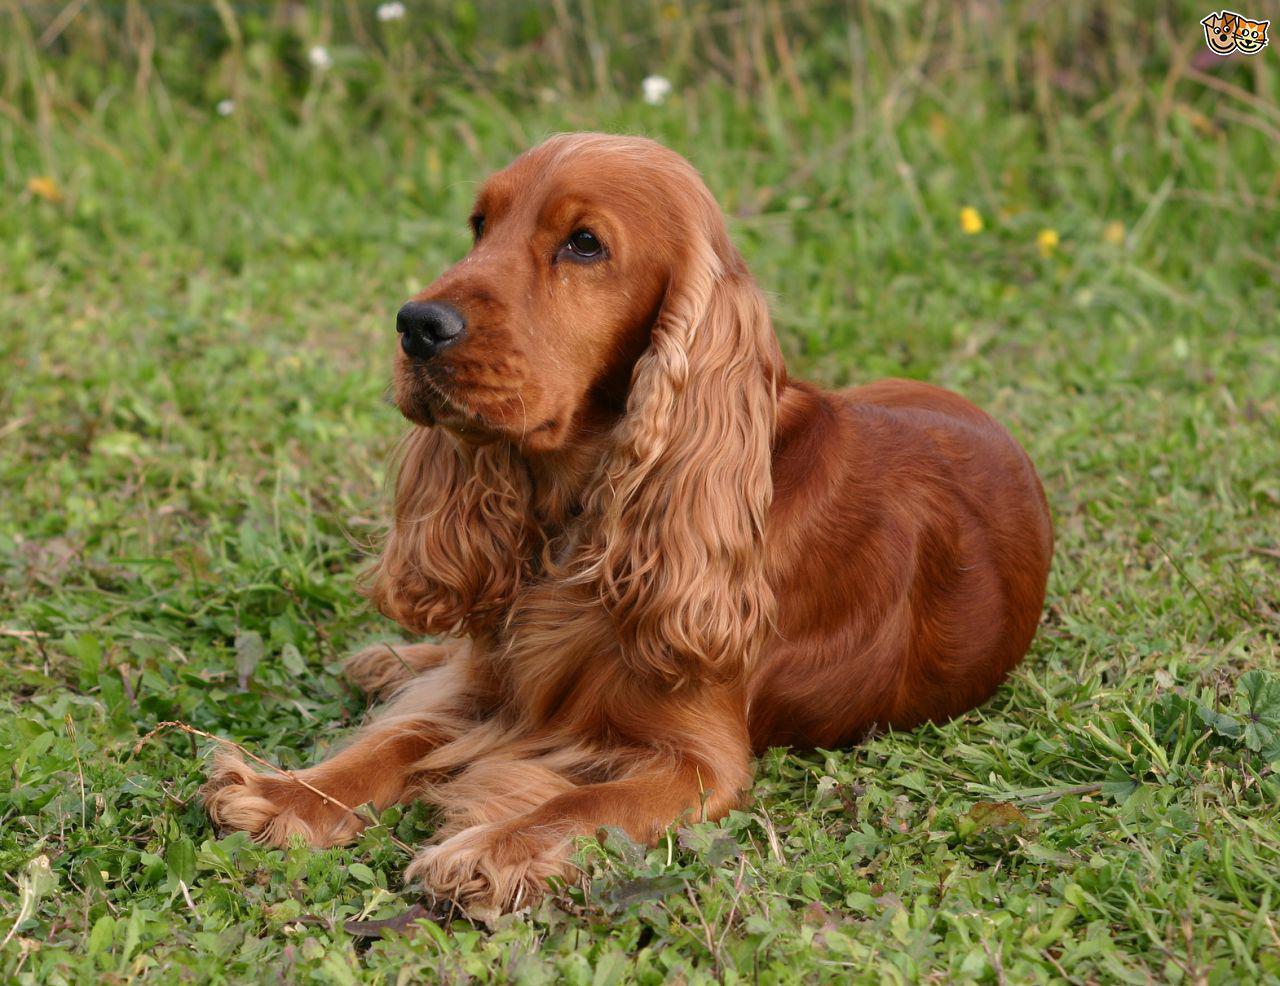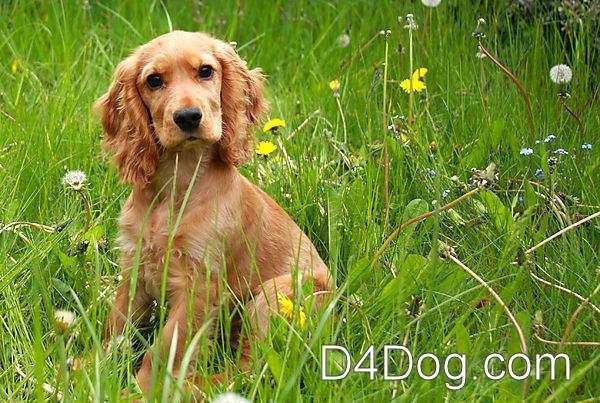The first image is the image on the left, the second image is the image on the right. Considering the images on both sides, is "One cocker spaniel is not pictured in an outdoor setting." valid? Answer yes or no. No. The first image is the image on the left, the second image is the image on the right. Assess this claim about the two images: "The dog in the image on the left is looking toward the camera.". Correct or not? Answer yes or no. No. The first image is the image on the left, the second image is the image on the right. Considering the images on both sides, is "There is at least one extended dog tongue in one of the images." valid? Answer yes or no. No. The first image is the image on the left, the second image is the image on the right. Considering the images on both sides, is "the dog in the image on the left is lying down" valid? Answer yes or no. Yes. 